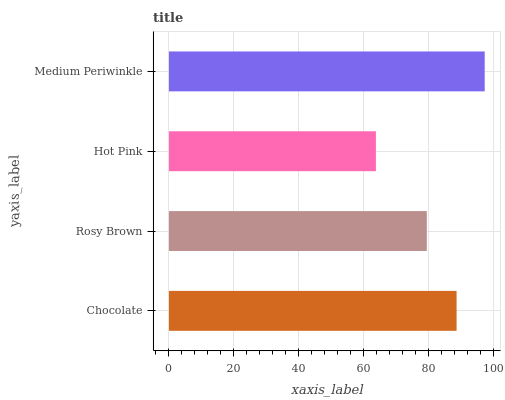Is Hot Pink the minimum?
Answer yes or no. Yes. Is Medium Periwinkle the maximum?
Answer yes or no. Yes. Is Rosy Brown the minimum?
Answer yes or no. No. Is Rosy Brown the maximum?
Answer yes or no. No. Is Chocolate greater than Rosy Brown?
Answer yes or no. Yes. Is Rosy Brown less than Chocolate?
Answer yes or no. Yes. Is Rosy Brown greater than Chocolate?
Answer yes or no. No. Is Chocolate less than Rosy Brown?
Answer yes or no. No. Is Chocolate the high median?
Answer yes or no. Yes. Is Rosy Brown the low median?
Answer yes or no. Yes. Is Rosy Brown the high median?
Answer yes or no. No. Is Chocolate the low median?
Answer yes or no. No. 